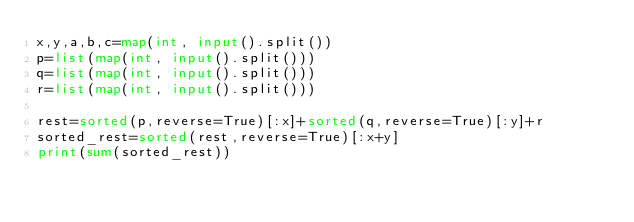Convert code to text. <code><loc_0><loc_0><loc_500><loc_500><_Python_>x,y,a,b,c=map(int, input().split())
p=list(map(int, input().split()))
q=list(map(int, input().split()))
r=list(map(int, input().split()))

rest=sorted(p,reverse=True)[:x]+sorted(q,reverse=True)[:y]+r
sorted_rest=sorted(rest,reverse=True)[:x+y]
print(sum(sorted_rest))</code> 